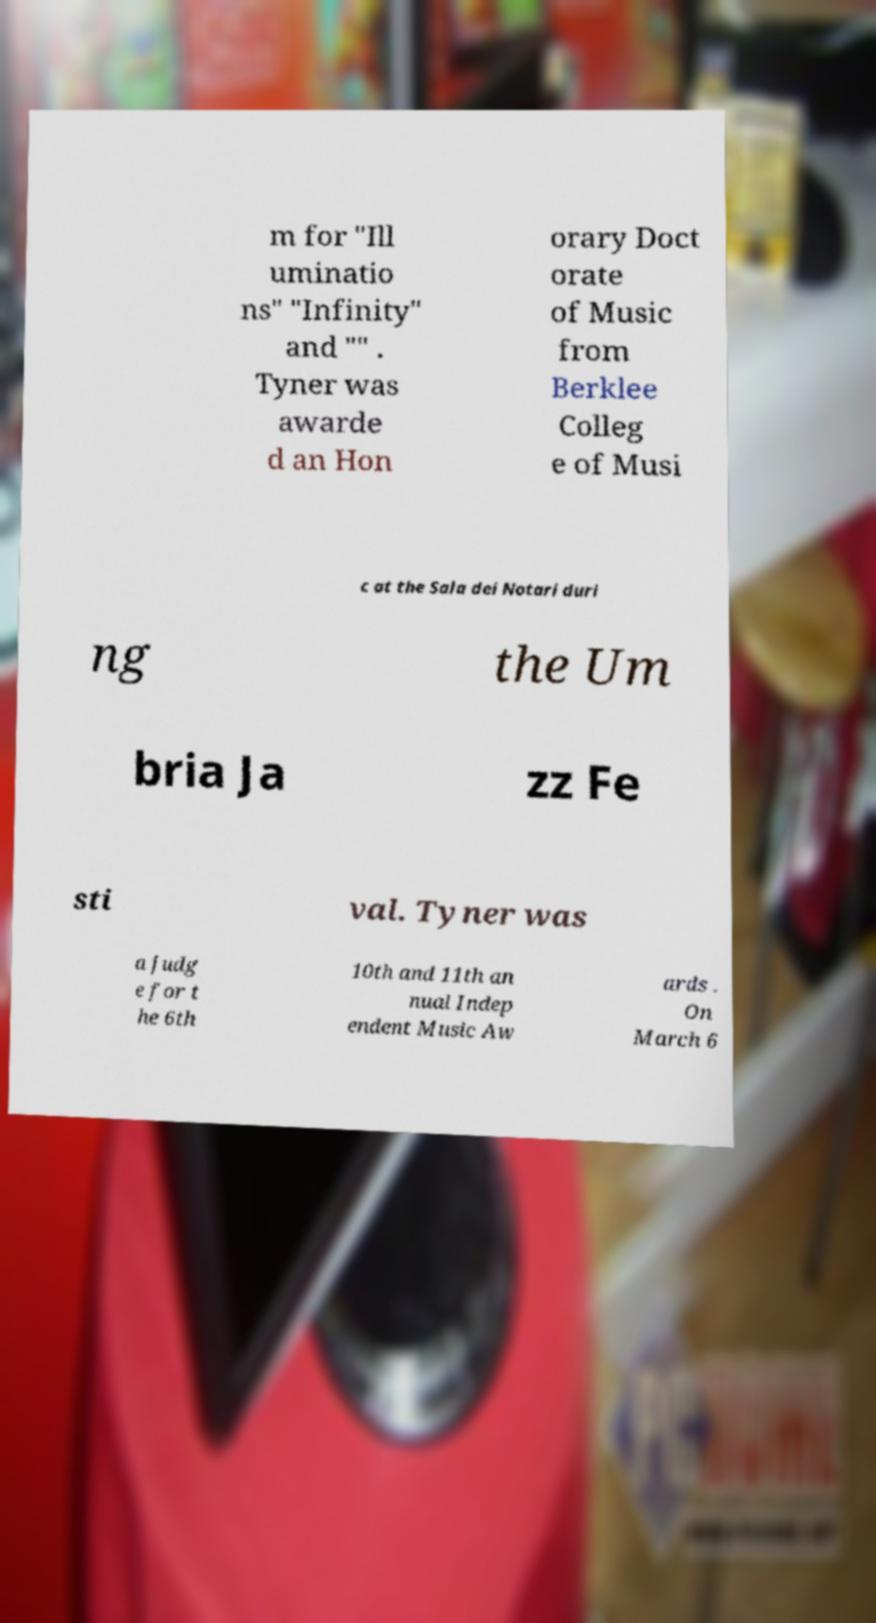Can you read and provide the text displayed in the image?This photo seems to have some interesting text. Can you extract and type it out for me? m for "Ill uminatio ns" "Infinity" and "" . Tyner was awarde d an Hon orary Doct orate of Music from Berklee Colleg e of Musi c at the Sala dei Notari duri ng the Um bria Ja zz Fe sti val. Tyner was a judg e for t he 6th 10th and 11th an nual Indep endent Music Aw ards . On March 6 